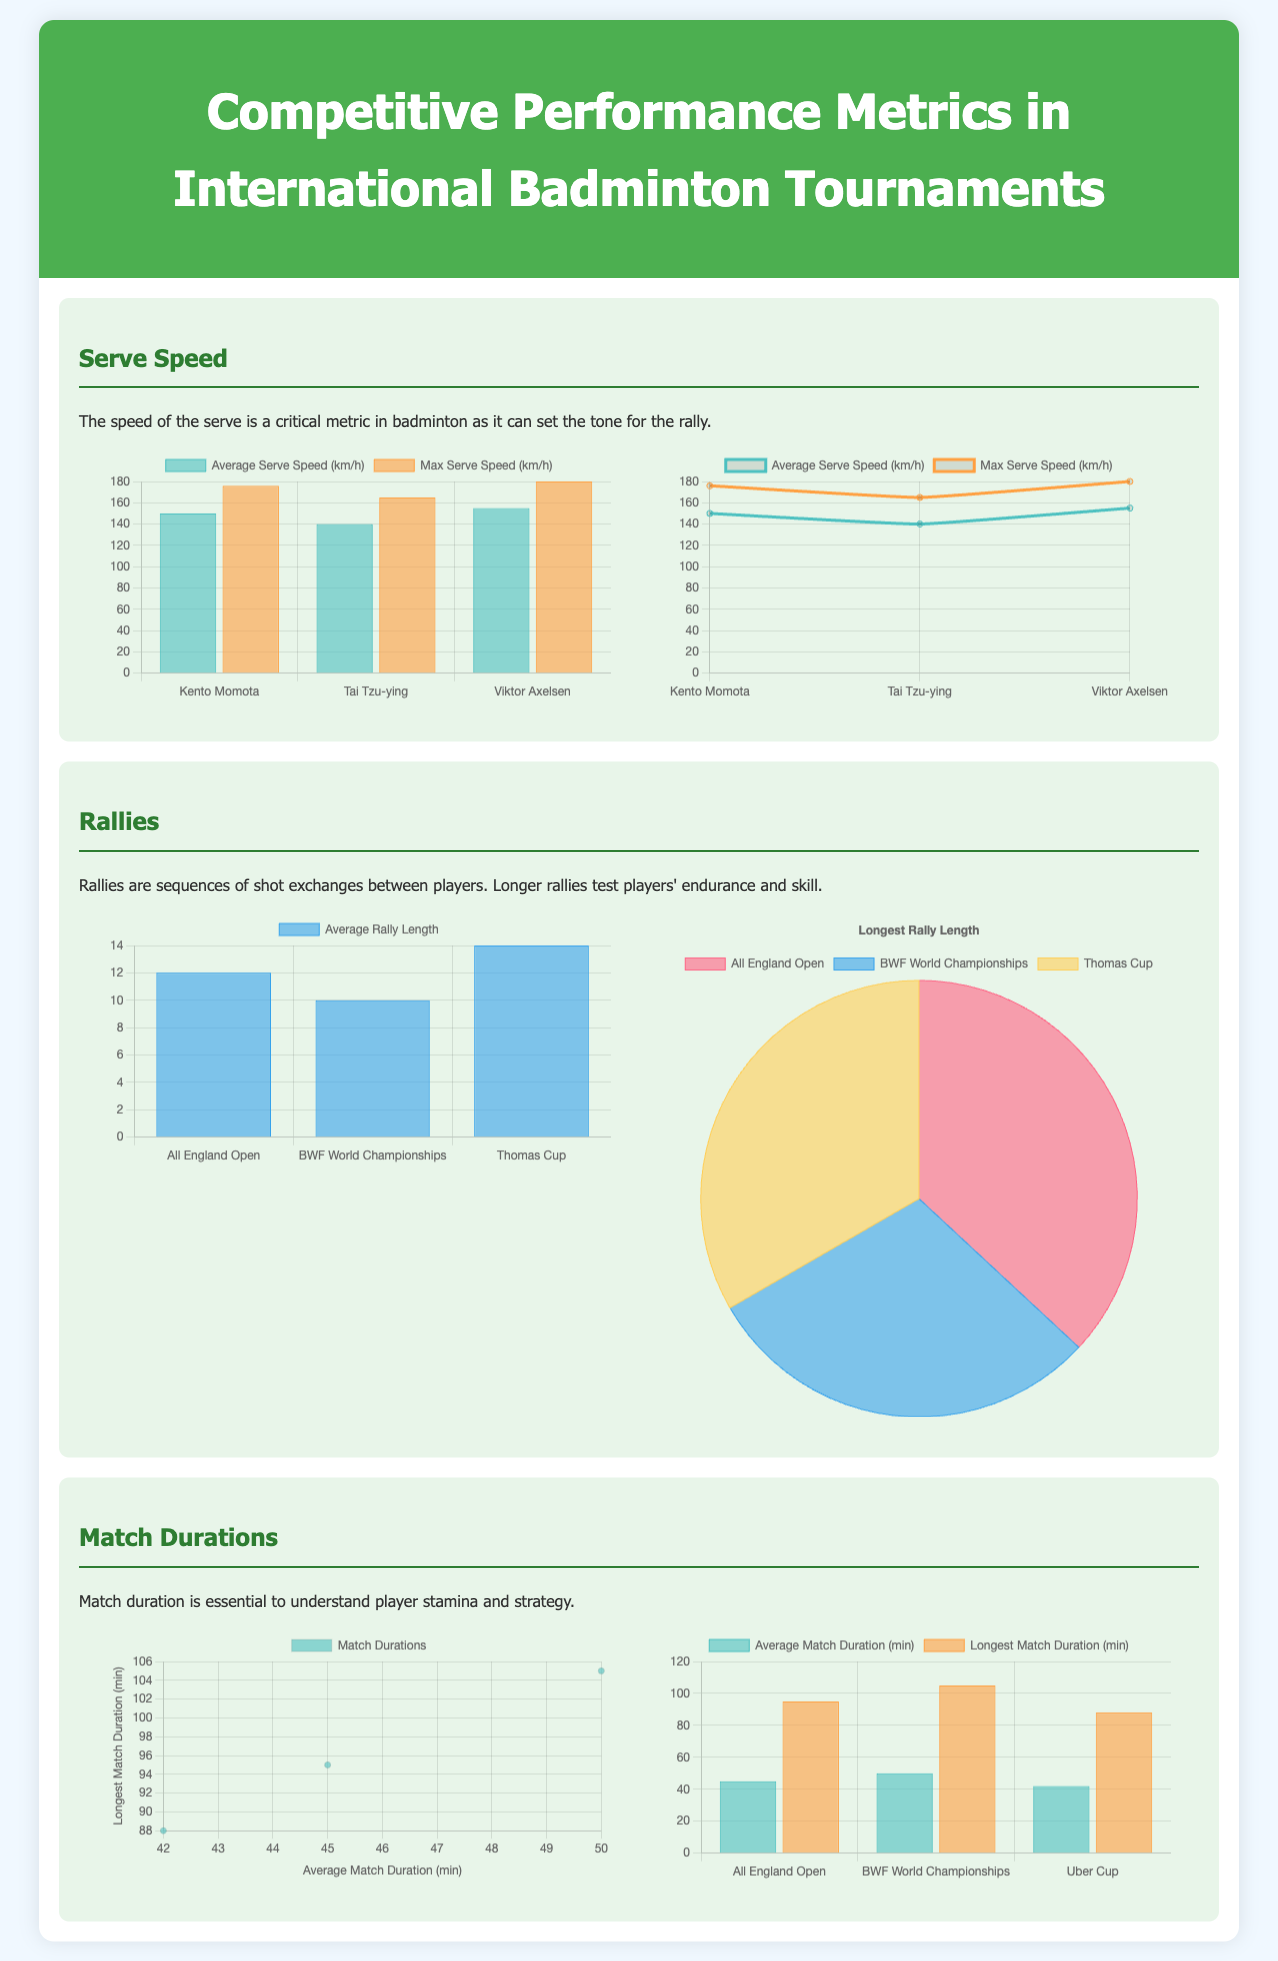What is the average serve speed of Kento Momota? The average serve speed of Kento Momota is indicated in the bar chart, which shows a value of 150 km/h.
Answer: 150 km/h What is the maximum serve speed of Viktor Axelsen? The maximum serve speed of Viktor Axelsen is provided in the comparison, which lists it as 180 km/h.
Answer: 180 km/h Which tournament has the longest average rally length? The bar chart displays the average rally lengths for the tournaments, with the Thomas Cup showing the longest average rally at 14 shots.
Answer: Thomas Cup What percentage of the rallies were longest in the All England Open? The pie chart indicates that the All England Open has the highest proportion of longest rallies, represented as 72%.
Answer: 72% What is the average match duration for the BWF World Championships? The bar chart reveals that the average match duration for the BWF World Championships is noted as 50 minutes.
Answer: 50 minutes What is the longest match duration recorded in the document? The scatter plot indicates the longest match duration is 105 minutes, as shown for one of the matches.
Answer: 105 minutes How many players are represented in the serve speed data? The document mentions serve speed data for three players: Kento Momota, Tai Tzu-ying, and Viktor Axelsen.
Answer: Three players What type of charts are used to represent rally lengths? The document utilizes both a bar chart and a pie chart to display the information regarding rally lengths.
Answer: Bar and pie charts What is the average match duration for the Uber Cup? The bar chart indicates that the average match duration for the Uber Cup is noted as 42 minutes.
Answer: 42 minutes 